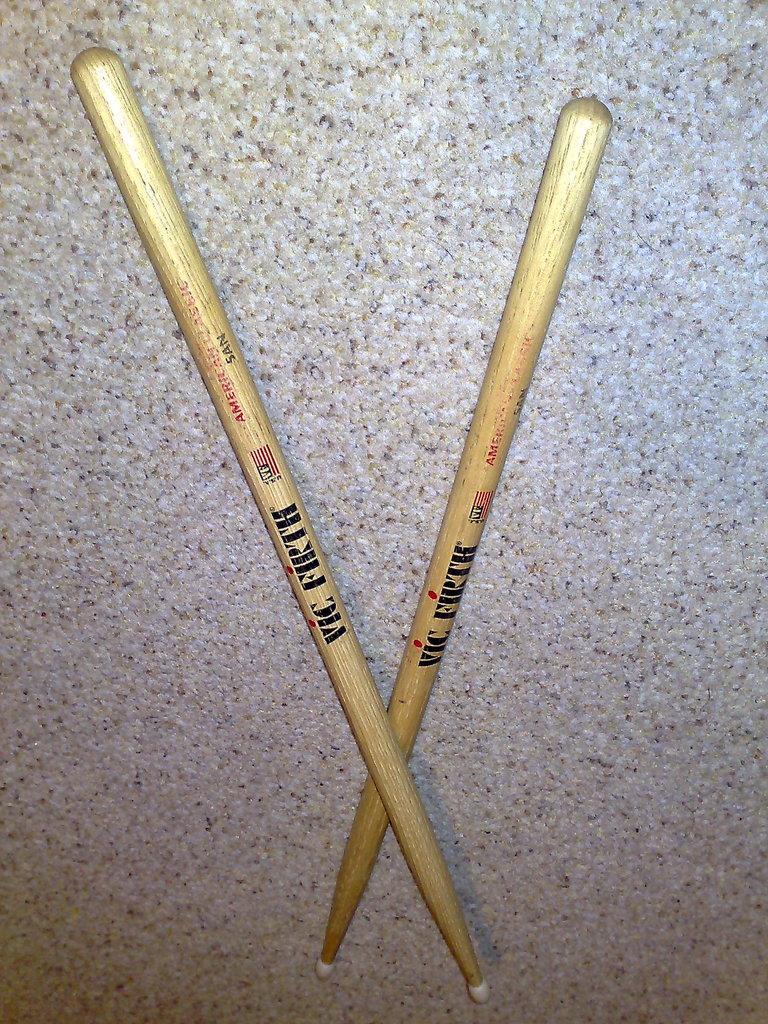How would you summarize this image in a sentence or two? In the image we can see there are two sticks which are kept on the ground in a cross shape. 